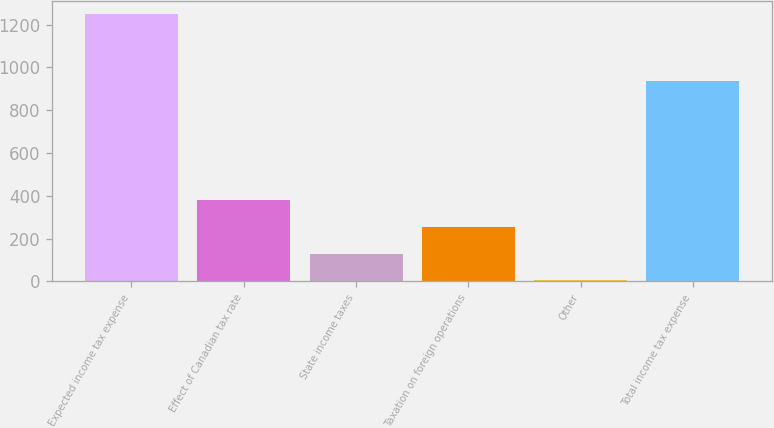Convert chart. <chart><loc_0><loc_0><loc_500><loc_500><bar_chart><fcel>Expected income tax expense<fcel>Effect of Canadian tax rate<fcel>State income taxes<fcel>Taxation on foreign operations<fcel>Other<fcel>Total income tax expense<nl><fcel>1249<fcel>378.2<fcel>129.4<fcel>253.8<fcel>5<fcel>936<nl></chart> 